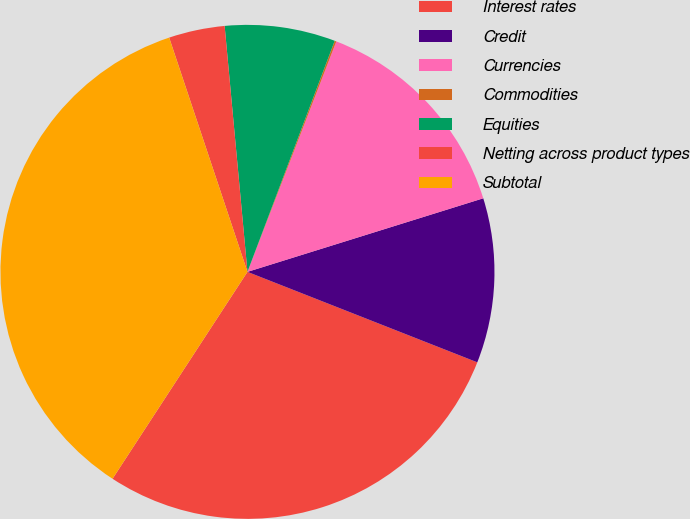<chart> <loc_0><loc_0><loc_500><loc_500><pie_chart><fcel>Interest rates<fcel>Credit<fcel>Currencies<fcel>Commodities<fcel>Equities<fcel>Netting across product types<fcel>Subtotal<nl><fcel>28.23%<fcel>10.78%<fcel>14.33%<fcel>0.11%<fcel>7.22%<fcel>3.66%<fcel>35.67%<nl></chart> 